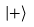<formula> <loc_0><loc_0><loc_500><loc_500>| + \rangle</formula> 